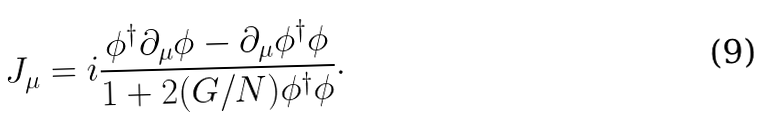<formula> <loc_0><loc_0><loc_500><loc_500>J _ { \mu } = i \frac { \phi ^ { \dagger } \partial _ { \mu } \phi - \partial _ { \mu } \phi ^ { \dagger } \phi } { 1 + 2 ( G / N ) \phi ^ { \dagger } \phi } .</formula> 